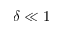Convert formula to latex. <formula><loc_0><loc_0><loc_500><loc_500>\delta \ll 1</formula> 